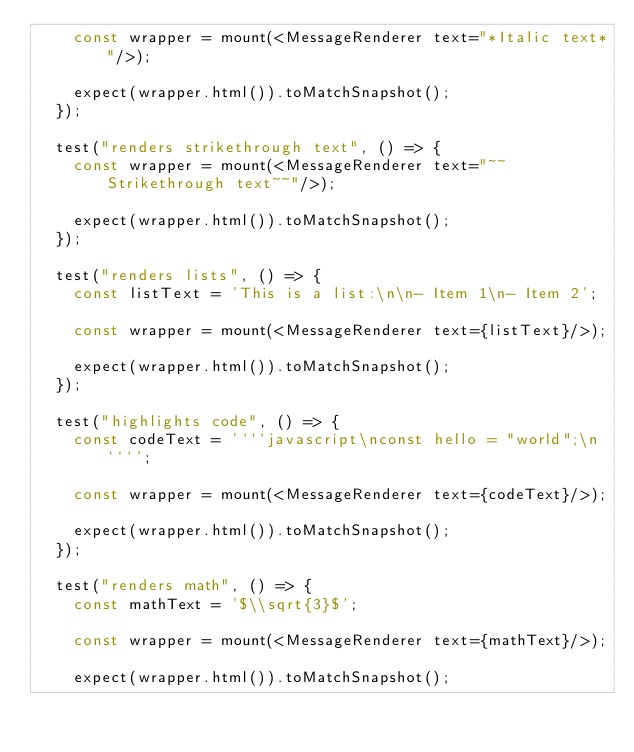<code> <loc_0><loc_0><loc_500><loc_500><_TypeScript_>    const wrapper = mount(<MessageRenderer text="*Italic text*"/>);

    expect(wrapper.html()).toMatchSnapshot();
  });

  test("renders strikethrough text", () => {
    const wrapper = mount(<MessageRenderer text="~~Strikethrough text~~"/>);

    expect(wrapper.html()).toMatchSnapshot();
  });

  test("renders lists", () => {
    const listText = 'This is a list:\n\n- Item 1\n- Item 2';

    const wrapper = mount(<MessageRenderer text={listText}/>);

    expect(wrapper.html()).toMatchSnapshot();
  });

  test("highlights code", () => {
    const codeText = '```javascript\nconst hello = "world";\n```';

    const wrapper = mount(<MessageRenderer text={codeText}/>);

    expect(wrapper.html()).toMatchSnapshot();
  });

  test("renders math", () => {
    const mathText = '$\\sqrt{3}$';

    const wrapper = mount(<MessageRenderer text={mathText}/>);

    expect(wrapper.html()).toMatchSnapshot();</code> 